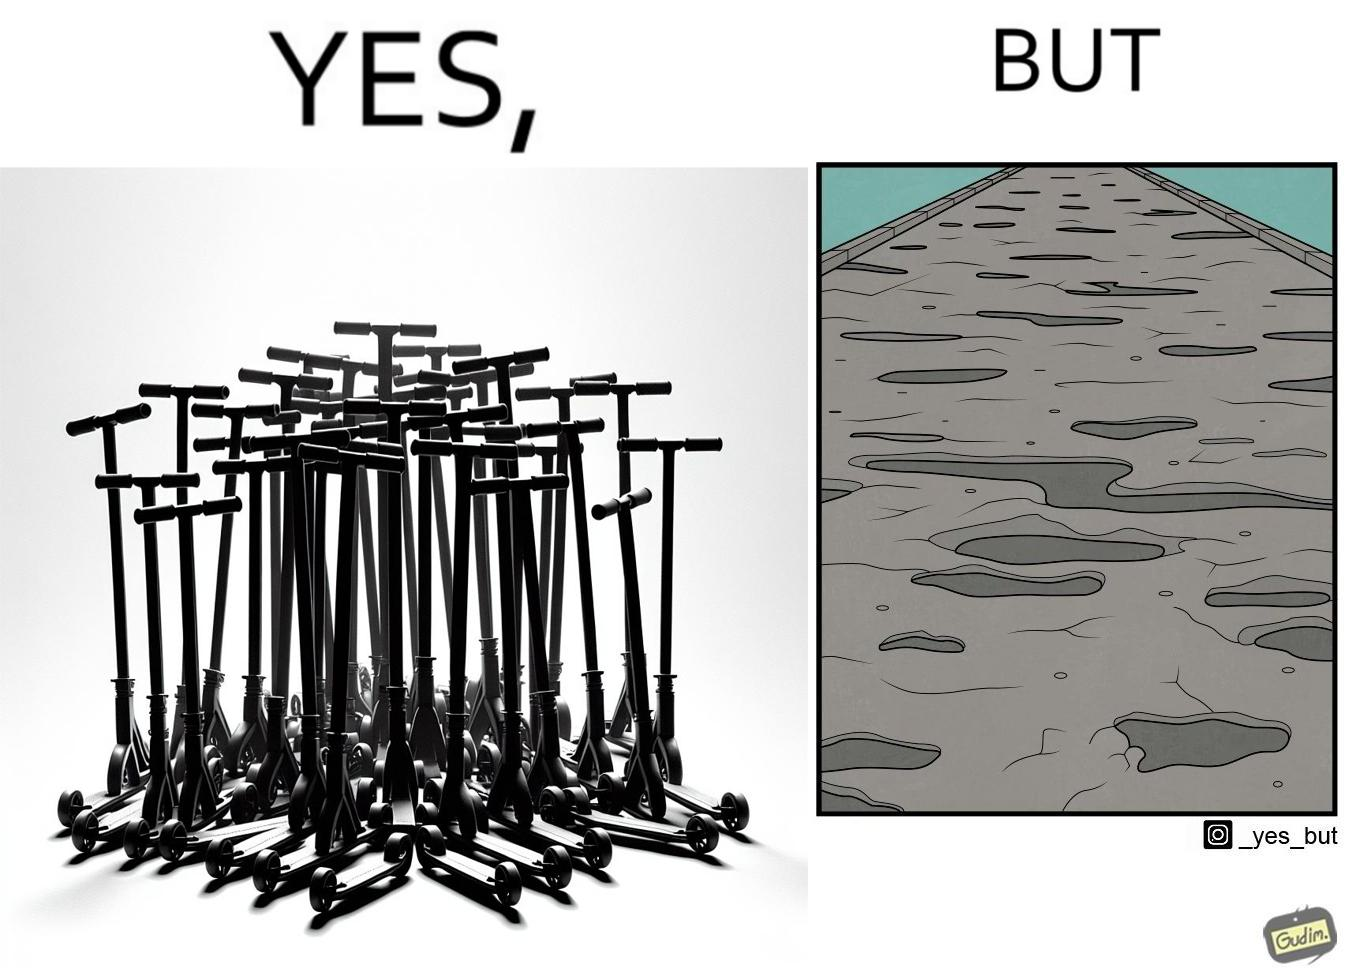Describe what you see in this image. The image is ironic, because even after when the skateboard scooters are available for someone to ride but the road has many potholes that it is not suitable to ride the scooters on such roads 